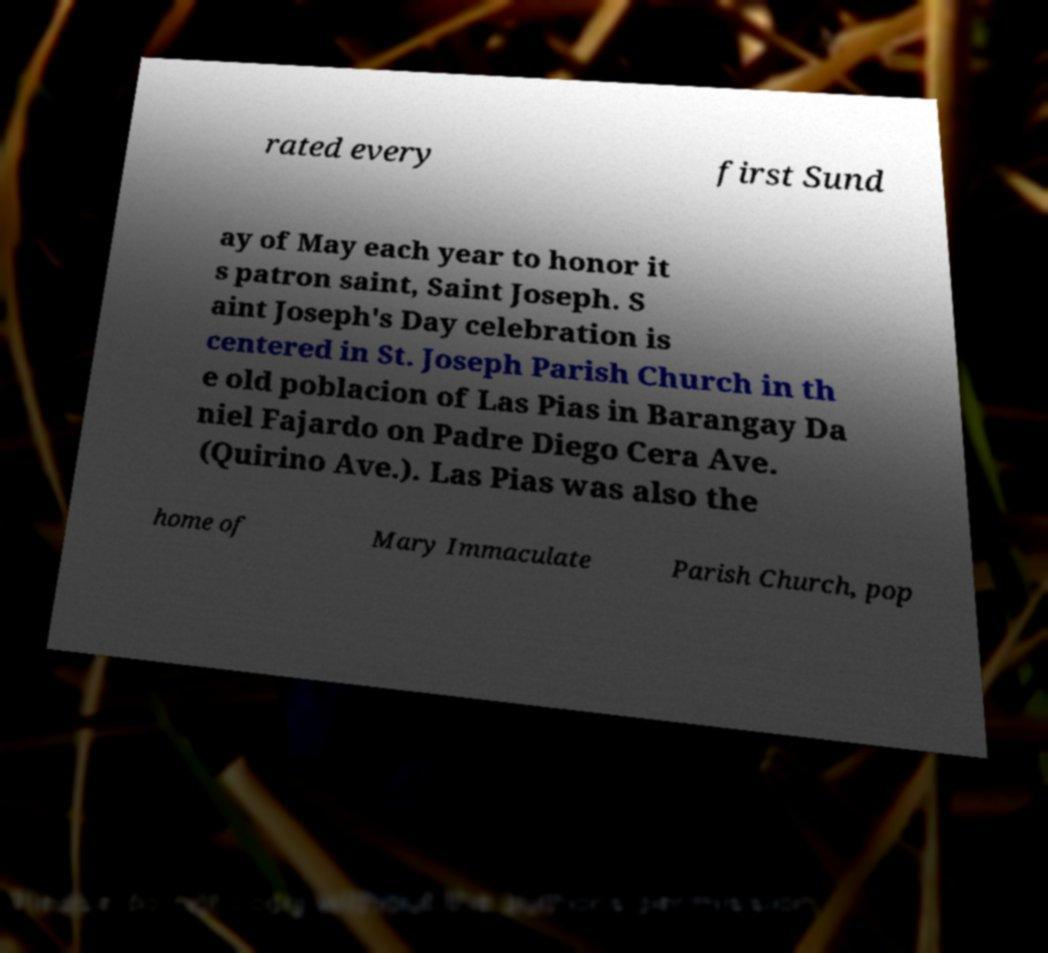What messages or text are displayed in this image? I need them in a readable, typed format. rated every first Sund ay of May each year to honor it s patron saint, Saint Joseph. S aint Joseph's Day celebration is centered in St. Joseph Parish Church in th e old poblacion of Las Pias in Barangay Da niel Fajardo on Padre Diego Cera Ave. (Quirino Ave.). Las Pias was also the home of Mary Immaculate Parish Church, pop 